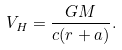<formula> <loc_0><loc_0><loc_500><loc_500>V _ { H } = \frac { G M } { c ( r + a ) } .</formula> 